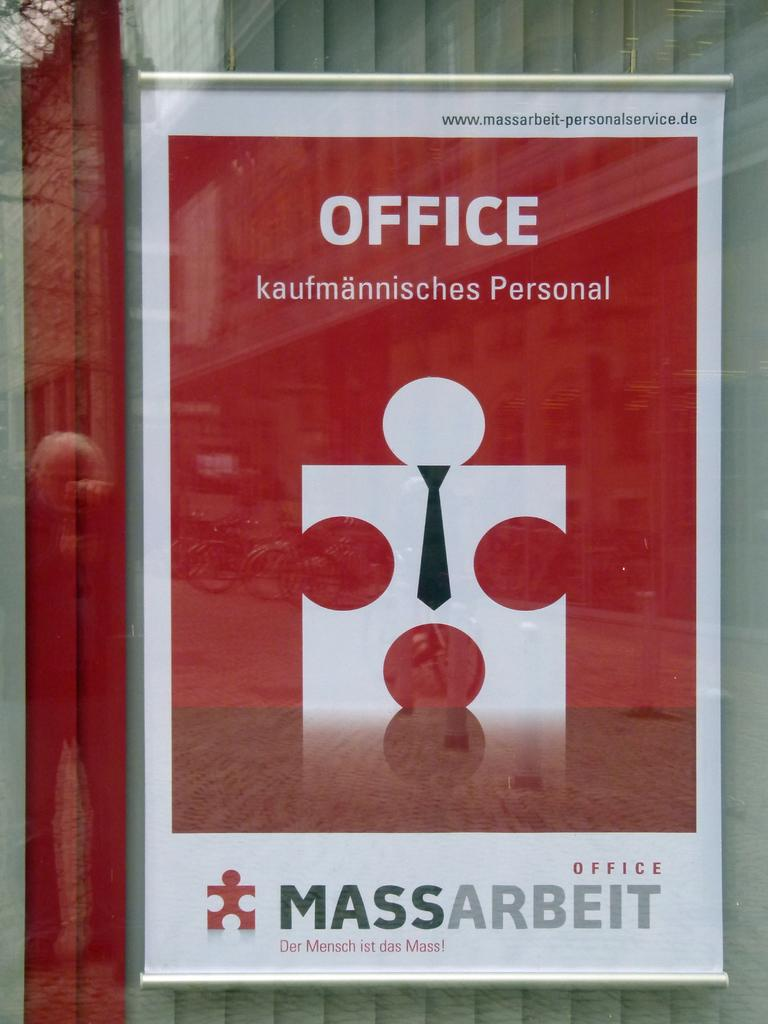What is the main object in the image? There is a board in the image. What is on the board? Something is written on the board. What else can be seen in the image? There is a wind blinder in the image. How are the board and wind blinder protected? The board and wind blinder are behind glass. What can be observed on the glass? There is a reflection of vehicles and a tree on the glass. Who is the writer of the text on the board in the image? There is no information about the writer of the text on the board in the image. Can you see the color of the wind blinder in the image? The image does not provide information about the color of the wind blinder. 